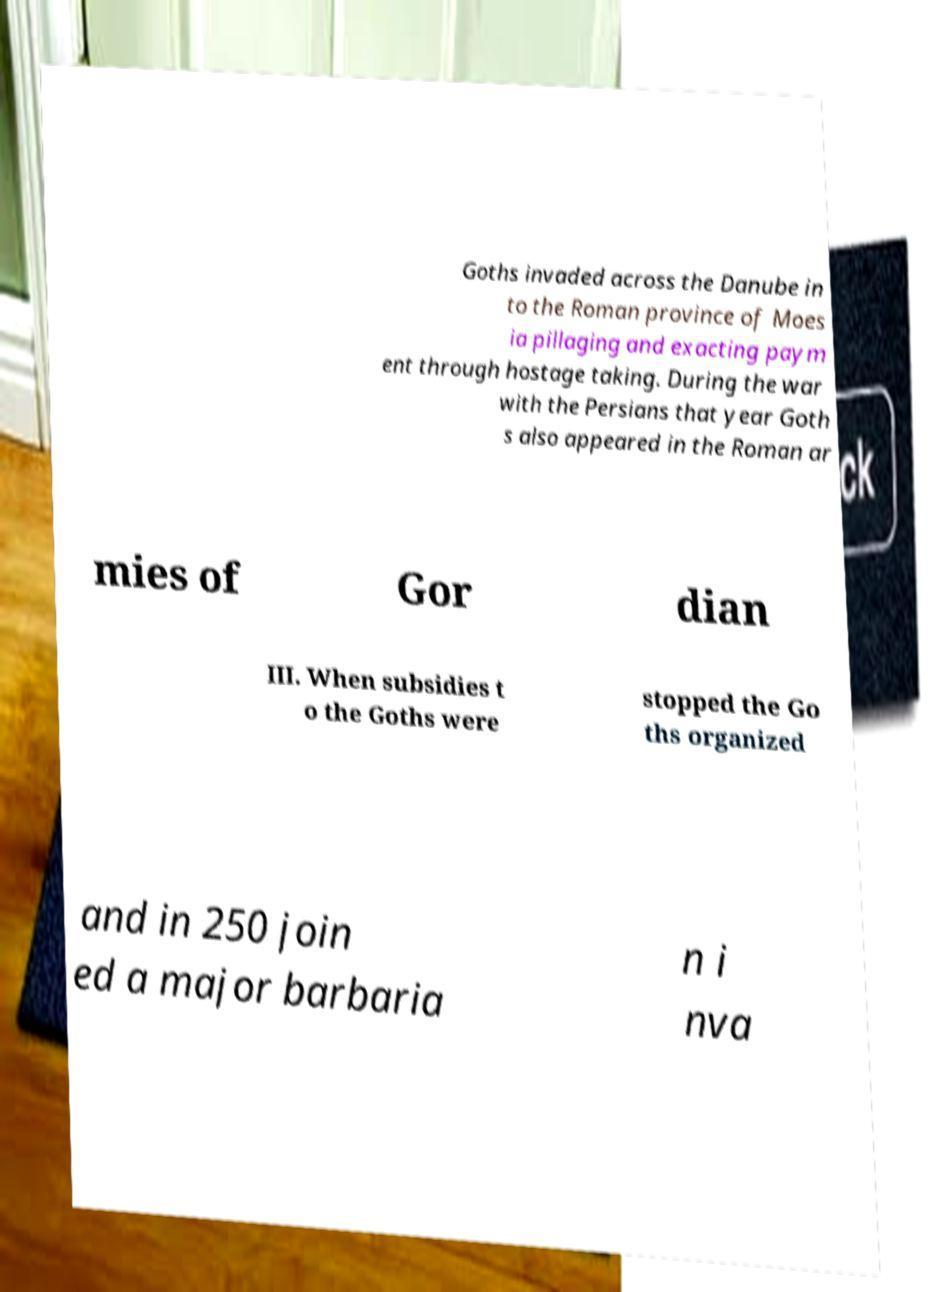Could you assist in decoding the text presented in this image and type it out clearly? Goths invaded across the Danube in to the Roman province of Moes ia pillaging and exacting paym ent through hostage taking. During the war with the Persians that year Goth s also appeared in the Roman ar mies of Gor dian III. When subsidies t o the Goths were stopped the Go ths organized and in 250 join ed a major barbaria n i nva 